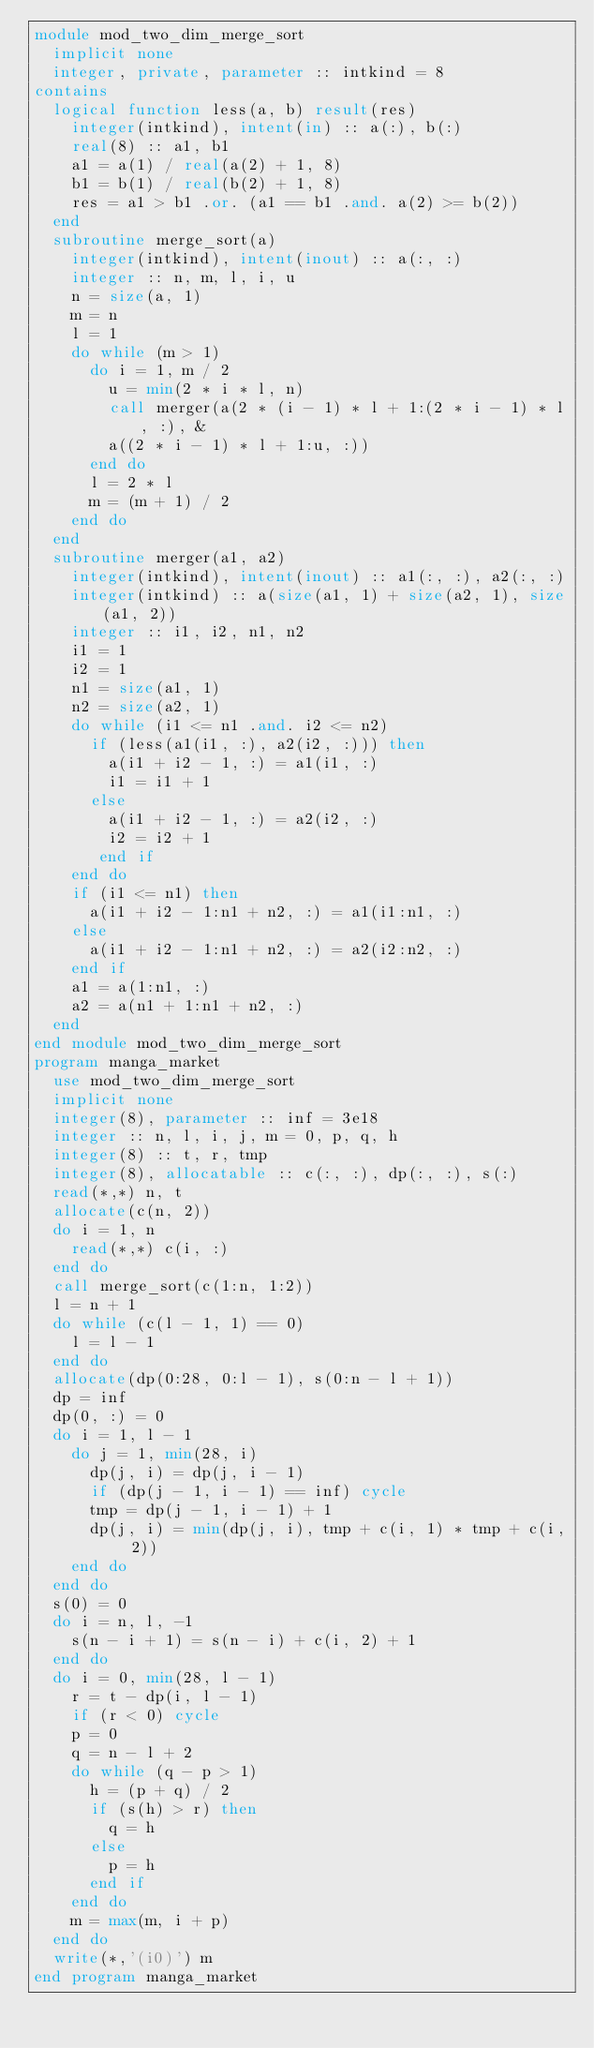Convert code to text. <code><loc_0><loc_0><loc_500><loc_500><_FORTRAN_>module mod_two_dim_merge_sort
  implicit none
  integer, private, parameter :: intkind = 8
contains
  logical function less(a, b) result(res)
    integer(intkind), intent(in) :: a(:), b(:)
    real(8) :: a1, b1
    a1 = a(1) / real(a(2) + 1, 8)
    b1 = b(1) / real(b(2) + 1, 8)
    res = a1 > b1 .or. (a1 == b1 .and. a(2) >= b(2))
  end
  subroutine merge_sort(a)
    integer(intkind), intent(inout) :: a(:, :)
    integer :: n, m, l, i, u
    n = size(a, 1)
    m = n
    l = 1
    do while (m > 1)
      do i = 1, m / 2
        u = min(2 * i * l, n)
        call merger(a(2 * (i - 1) * l + 1:(2 * i - 1) * l, :), &
        a((2 * i - 1) * l + 1:u, :))
      end do
      l = 2 * l
      m = (m + 1) / 2
    end do
  end
  subroutine merger(a1, a2)
    integer(intkind), intent(inout) :: a1(:, :), a2(:, :)
    integer(intkind) :: a(size(a1, 1) + size(a2, 1), size(a1, 2))
    integer :: i1, i2, n1, n2
    i1 = 1
    i2 = 1
    n1 = size(a1, 1)
    n2 = size(a2, 1)
    do while (i1 <= n1 .and. i2 <= n2)
      if (less(a1(i1, :), a2(i2, :))) then
        a(i1 + i2 - 1, :) = a1(i1, :)
        i1 = i1 + 1
      else
        a(i1 + i2 - 1, :) = a2(i2, :)
        i2 = i2 + 1
       end if
    end do
    if (i1 <= n1) then
      a(i1 + i2 - 1:n1 + n2, :) = a1(i1:n1, :)
    else
      a(i1 + i2 - 1:n1 + n2, :) = a2(i2:n2, :)
    end if
    a1 = a(1:n1, :)
    a2 = a(n1 + 1:n1 + n2, :)
  end
end module mod_two_dim_merge_sort
program manga_market
  use mod_two_dim_merge_sort
  implicit none
  integer(8), parameter :: inf = 3e18
  integer :: n, l, i, j, m = 0, p, q, h
  integer(8) :: t, r, tmp
  integer(8), allocatable :: c(:, :), dp(:, :), s(:)
  read(*,*) n, t
  allocate(c(n, 2))
  do i = 1, n
    read(*,*) c(i, :)
  end do
  call merge_sort(c(1:n, 1:2))
  l = n + 1
  do while (c(l - 1, 1) == 0)
    l = l - 1
  end do
  allocate(dp(0:28, 0:l - 1), s(0:n - l + 1))
  dp = inf
  dp(0, :) = 0
  do i = 1, l - 1
    do j = 1, min(28, i)
      dp(j, i) = dp(j, i - 1)
      if (dp(j - 1, i - 1) == inf) cycle
      tmp = dp(j - 1, i - 1) + 1
      dp(j, i) = min(dp(j, i), tmp + c(i, 1) * tmp + c(i, 2))
    end do
  end do
  s(0) = 0
  do i = n, l, -1
    s(n - i + 1) = s(n - i) + c(i, 2) + 1
  end do
  do i = 0, min(28, l - 1)
    r = t - dp(i, l - 1)
    if (r < 0) cycle
    p = 0
    q = n - l + 2
    do while (q - p > 1)
      h = (p + q) / 2
      if (s(h) > r) then
        q = h
      else
        p = h
      end if
    end do
    m = max(m, i + p)
  end do
  write(*,'(i0)') m
end program manga_market</code> 